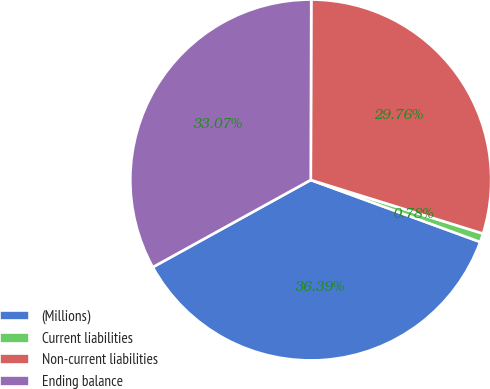<chart> <loc_0><loc_0><loc_500><loc_500><pie_chart><fcel>(Millions)<fcel>Current liabilities<fcel>Non-current liabilities<fcel>Ending balance<nl><fcel>36.39%<fcel>0.78%<fcel>29.76%<fcel>33.07%<nl></chart> 